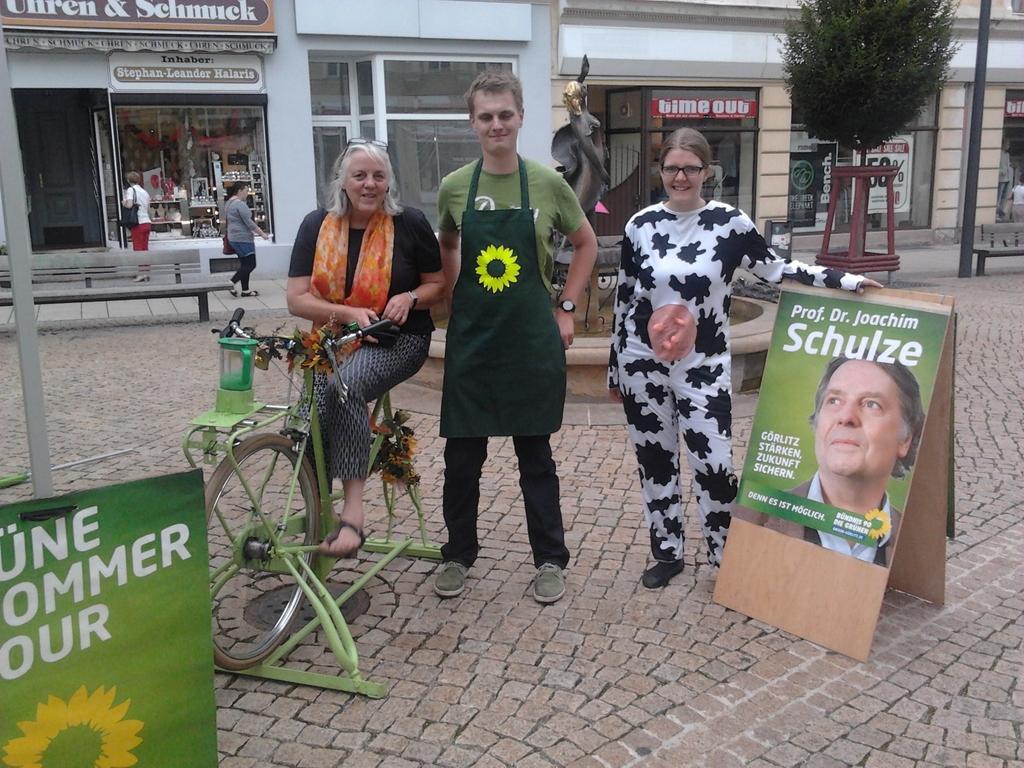In one or two sentences, can you explain what this image depicts? The picture is clicked on a street where a lady is sitting on a bicycle and two people beside her. There is also a poster called prof DR. Joachim Schulze to the right side of the image. In the background we observe few shops which have glass doors. 